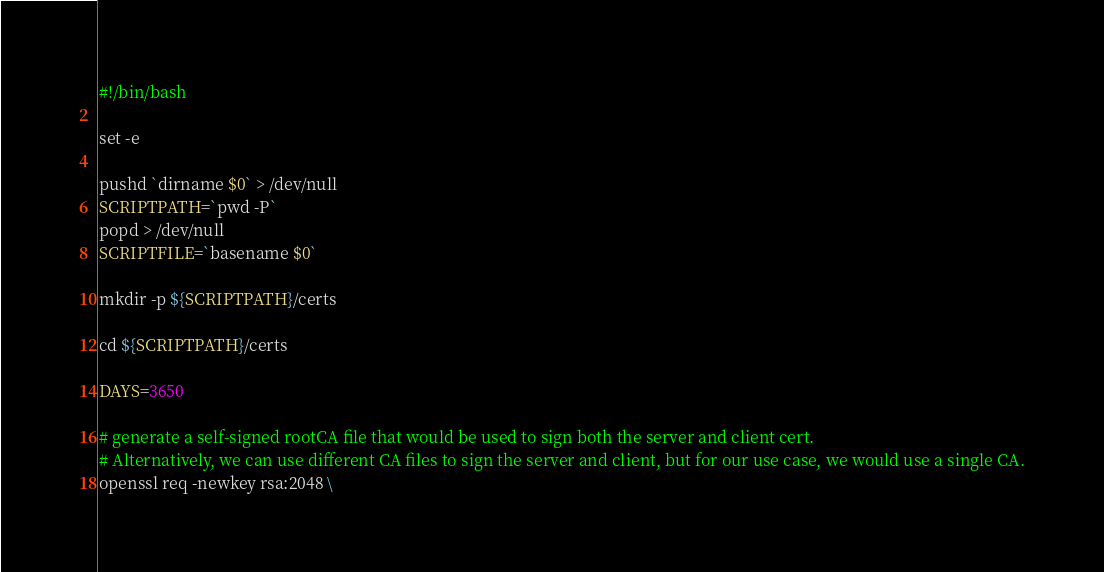Convert code to text. <code><loc_0><loc_0><loc_500><loc_500><_Bash_>#!/bin/bash

set -e

pushd `dirname $0` > /dev/null
SCRIPTPATH=`pwd -P`
popd > /dev/null
SCRIPTFILE=`basename $0`

mkdir -p ${SCRIPTPATH}/certs

cd ${SCRIPTPATH}/certs

DAYS=3650

# generate a self-signed rootCA file that would be used to sign both the server and client cert.
# Alternatively, we can use different CA files to sign the server and client, but for our use case, we would use a single CA.
openssl req -newkey rsa:2048 \</code> 